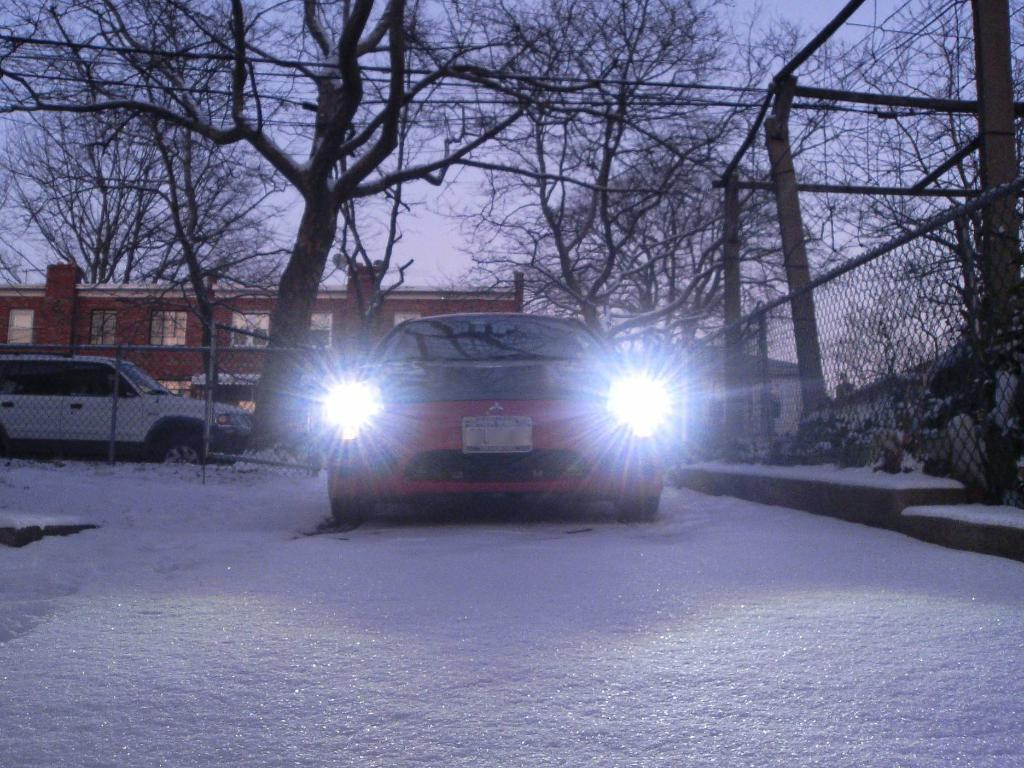What is the main subject of the image? There is a car in the image. What is surrounding the car in the image? There is a lot of ice around the car. Can you describe the background of the image? There is a vehicle, trees, and a building in the background of the image. Who is the partner of the car's creator in the image? There is no mention of a car's creator or a partner in the image. Can you tell me how many monkeys are sitting on the car in the image? There are no monkeys present in the image. 